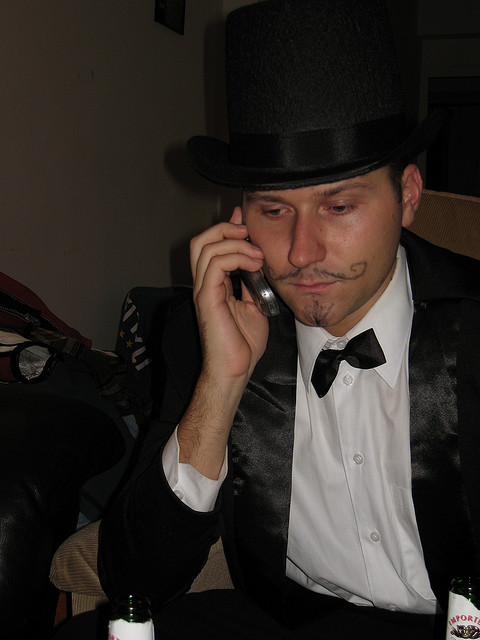What kind of phone is he using?
A. cellular
B. pay
C. rotary
D. landline
Answer with the option's letter from the given choices directly. A 